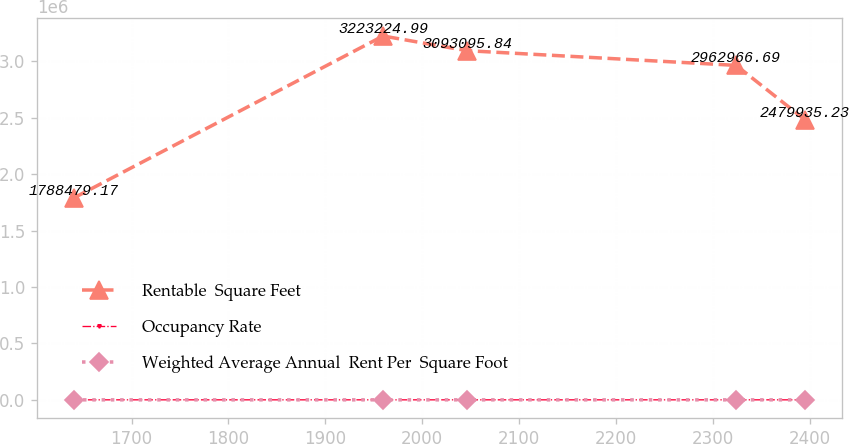Convert chart. <chart><loc_0><loc_0><loc_500><loc_500><line_chart><ecel><fcel>Rentable  Square Feet<fcel>Occupancy Rate<fcel>Weighted Average Annual  Rent Per  Square Foot<nl><fcel>1640.38<fcel>1.78848e+06<fcel>96.55<fcel>29.86<nl><fcel>1959.63<fcel>3.22322e+06<fcel>77.87<fcel>36.19<nl><fcel>2046.38<fcel>3.0931e+06<fcel>113.53<fcel>38.37<nl><fcel>2324.02<fcel>2.96297e+06<fcel>81.88<fcel>37.16<nl><fcel>2395.19<fcel>2.47994e+06<fcel>117.1<fcel>28.69<nl></chart> 